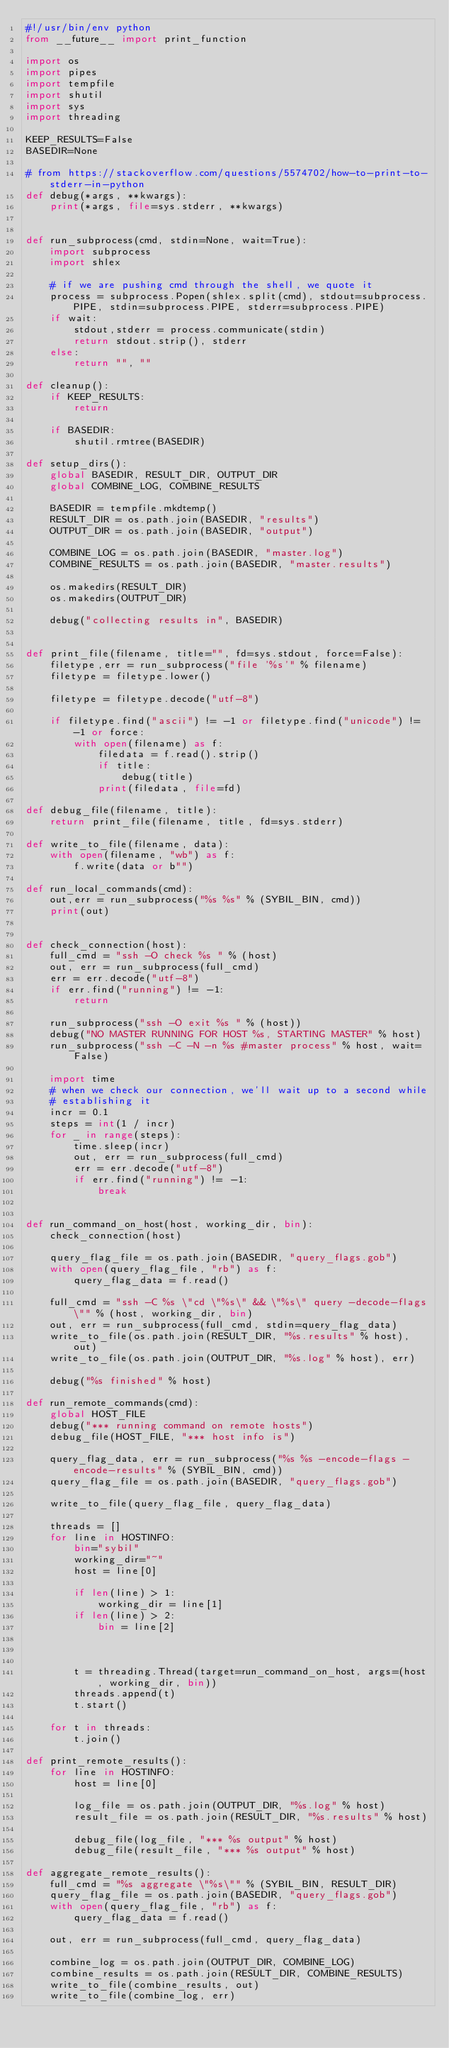Convert code to text. <code><loc_0><loc_0><loc_500><loc_500><_Python_>#!/usr/bin/env python
from __future__ import print_function

import os
import pipes
import tempfile
import shutil
import sys
import threading

KEEP_RESULTS=False
BASEDIR=None

# from https://stackoverflow.com/questions/5574702/how-to-print-to-stderr-in-python
def debug(*args, **kwargs):
    print(*args, file=sys.stderr, **kwargs)


def run_subprocess(cmd, stdin=None, wait=True):
    import subprocess
    import shlex

    # if we are pushing cmd through the shell, we quote it
    process = subprocess.Popen(shlex.split(cmd), stdout=subprocess.PIPE, stdin=subprocess.PIPE, stderr=subprocess.PIPE)
    if wait:
        stdout,stderr = process.communicate(stdin)
        return stdout.strip(), stderr
    else:
        return "", ""

def cleanup():
    if KEEP_RESULTS:
        return

    if BASEDIR:
        shutil.rmtree(BASEDIR)

def setup_dirs():
    global BASEDIR, RESULT_DIR, OUTPUT_DIR
    global COMBINE_LOG, COMBINE_RESULTS

    BASEDIR = tempfile.mkdtemp()
    RESULT_DIR = os.path.join(BASEDIR, "results")
    OUTPUT_DIR = os.path.join(BASEDIR, "output")

    COMBINE_LOG = os.path.join(BASEDIR, "master.log")
    COMBINE_RESULTS = os.path.join(BASEDIR, "master.results")

    os.makedirs(RESULT_DIR)
    os.makedirs(OUTPUT_DIR)

    debug("collecting results in", BASEDIR)


def print_file(filename, title="", fd=sys.stdout, force=False):
    filetype,err = run_subprocess("file '%s'" % filename)
    filetype = filetype.lower()

    filetype = filetype.decode("utf-8")

    if filetype.find("ascii") != -1 or filetype.find("unicode") != -1 or force:
        with open(filename) as f:
            filedata = f.read().strip()
            if title:
                debug(title)
            print(filedata, file=fd)

def debug_file(filename, title):
    return print_file(filename, title, fd=sys.stderr)

def write_to_file(filename, data):
    with open(filename, "wb") as f:
        f.write(data or b"")

def run_local_commands(cmd):
    out,err = run_subprocess("%s %s" % (SYBIL_BIN, cmd))
    print(out)


def check_connection(host):
    full_cmd = "ssh -O check %s " % (host)
    out, err = run_subprocess(full_cmd)
    err = err.decode("utf-8")
    if err.find("running") != -1:
        return

    run_subprocess("ssh -O exit %s " % (host))
    debug("NO MASTER RUNNING FOR HOST %s, STARTING MASTER" % host)
    run_subprocess("ssh -C -N -n %s #master process" % host, wait=False)

    import time
    # when we check our connection, we'll wait up to a second while
    # establishing it
    incr = 0.1
    steps = int(1 / incr)
    for _ in range(steps):
        time.sleep(incr)
        out, err = run_subprocess(full_cmd)
        err = err.decode("utf-8")
        if err.find("running") != -1:
            break


def run_command_on_host(host, working_dir, bin):
    check_connection(host)

    query_flag_file = os.path.join(BASEDIR, "query_flags.gob")
    with open(query_flag_file, "rb") as f:
        query_flag_data = f.read()

    full_cmd = "ssh -C %s \"cd \"%s\" && \"%s\" query -decode-flags\"" % (host, working_dir, bin)
    out, err = run_subprocess(full_cmd, stdin=query_flag_data)
    write_to_file(os.path.join(RESULT_DIR, "%s.results" % host), out)
    write_to_file(os.path.join(OUTPUT_DIR, "%s.log" % host), err)

    debug("%s finished" % host)

def run_remote_commands(cmd):
    global HOST_FILE
    debug("*** running command on remote hosts")
    debug_file(HOST_FILE, "*** host info is")

    query_flag_data, err = run_subprocess("%s %s -encode-flags -encode-results" % (SYBIL_BIN, cmd))
    query_flag_file = os.path.join(BASEDIR, "query_flags.gob")

    write_to_file(query_flag_file, query_flag_data)

    threads = []
    for line in HOSTINFO:
        bin="sybil"
        working_dir="~"
        host = line[0]

        if len(line) > 1:
            working_dir = line[1]
        if len(line) > 2:
            bin = line[2]



        t = threading.Thread(target=run_command_on_host, args=(host, working_dir, bin))
        threads.append(t)
        t.start()

    for t in threads:
        t.join()

def print_remote_results():
    for line in HOSTINFO:
        host = line[0]

        log_file = os.path.join(OUTPUT_DIR, "%s.log" % host)
        result_file = os.path.join(RESULT_DIR, "%s.results" % host)

        debug_file(log_file, "*** %s output" % host)
        debug_file(result_file, "*** %s output" % host)

def aggregate_remote_results():
    full_cmd = "%s aggregate \"%s\"" % (SYBIL_BIN, RESULT_DIR)
    query_flag_file = os.path.join(BASEDIR, "query_flags.gob")
    with open(query_flag_file, "rb") as f:
        query_flag_data = f.read()

    out, err = run_subprocess(full_cmd, query_flag_data)

    combine_log = os.path.join(OUTPUT_DIR, COMBINE_LOG)
    combine_results = os.path.join(RESULT_DIR, COMBINE_RESULTS)
    write_to_file(combine_results, out)
    write_to_file(combine_log, err)
</code> 